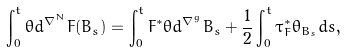<formula> <loc_0><loc_0><loc_500><loc_500>\int _ { 0 } ^ { t } \theta d ^ { \nabla ^ { N } } F ( B _ { s } ) = \int _ { 0 } ^ { t } F ^ { * } \theta d ^ { \nabla ^ { g } } B _ { s } + \frac { 1 } { 2 } \int _ { 0 } ^ { t } \tau _ { F } ^ { * } \theta _ { B _ { s } } d s ,</formula> 